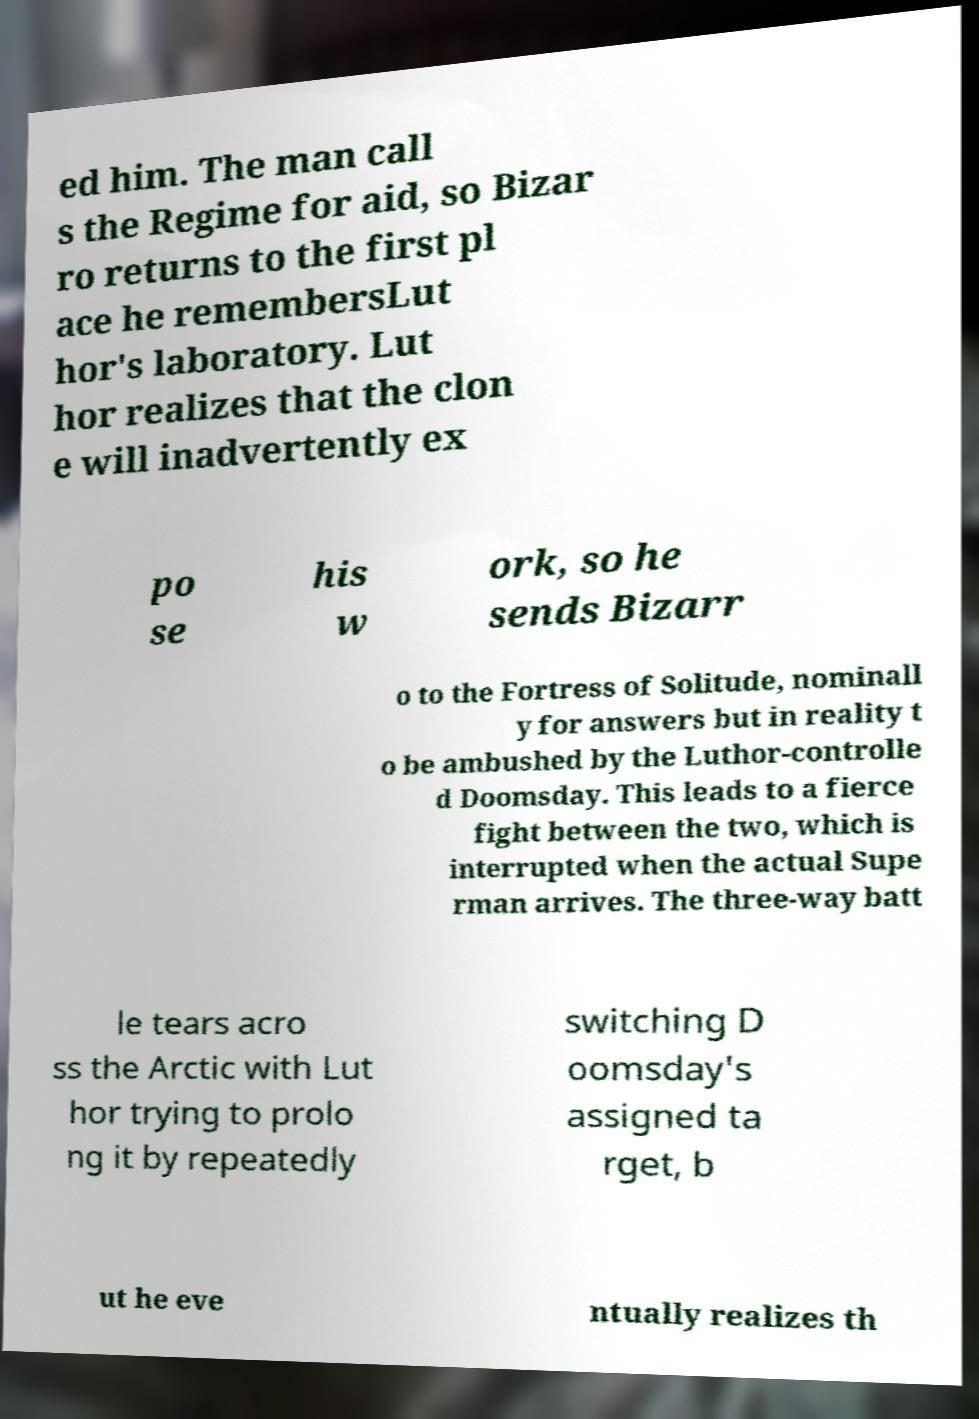Please identify and transcribe the text found in this image. ed him. The man call s the Regime for aid, so Bizar ro returns to the first pl ace he remembersLut hor's laboratory. Lut hor realizes that the clon e will inadvertently ex po se his w ork, so he sends Bizarr o to the Fortress of Solitude, nominall y for answers but in reality t o be ambushed by the Luthor-controlle d Doomsday. This leads to a fierce fight between the two, which is interrupted when the actual Supe rman arrives. The three-way batt le tears acro ss the Arctic with Lut hor trying to prolo ng it by repeatedly switching D oomsday's assigned ta rget, b ut he eve ntually realizes th 